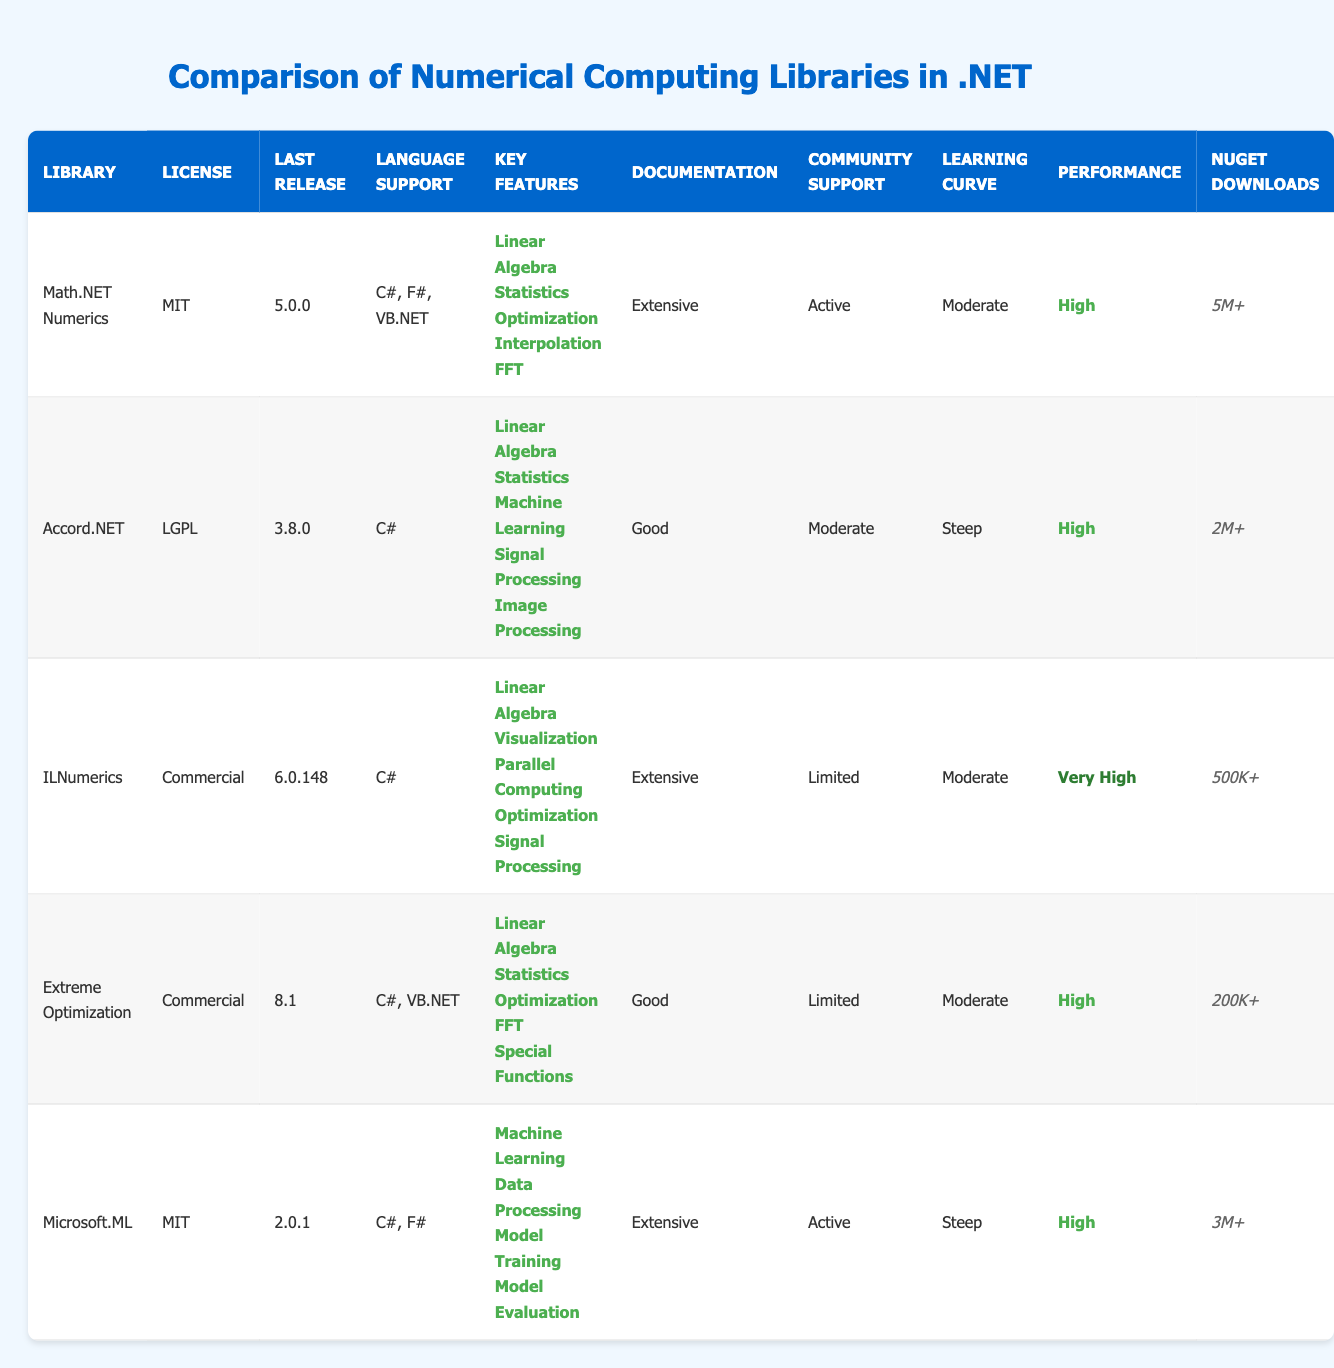What is the last release version of Math.NET Numerics? According to the table, the last release version of Math.NET Numerics is listed in the "Last Release" column as 5.0.0.
Answer: 5.0.0 Which library has the highest NuGet downloads? By comparing the "NuGet Downloads" column, Math.NET Numerics has the highest downloads at 5M+.
Answer: Math.NET Numerics Is ILNumerics community support active? Looking at the "Community Support" column, ILNumerics is marked as having limited community support. Therefore, the statement is false.
Answer: No How many libraries support both C# and F#? By examining the "Language Support" column, Math.NET Numerics and Microsoft.ML support both C# and F#. Thus, there are two libraries that support both languages.
Answer: 2 What is the performance rating of Accord.NET? From the "Performance" column, Accord.NET has a rating of High.
Answer: High Does Extreme Optimization provide features for image processing? The "Key Features" column for Extreme Optimization does not mention image processing. Therefore, it does not provide this feature.
Answer: No Which library has a steeper learning curve, Accord.NET or Microsoft.ML? Comparing the "Learning Curve" column, both Accord.NET and Microsoft.ML are rated as steep. Therefore, they are equally on the steep learning curve.
Answer: They are equal What features are present in both Math.NET Numerics and Accord.NET? To find common features, we look at the key features of both libraries: Math.NET Numerics has Linear Algebra, Statistics, and Optimization, while Accord.NET offers Linear Algebra and Statistics. Both libraries have Linear Algebra and Statistics in common.
Answer: Linear Algebra, Statistics Which library has the least documentation rating? In the "Documentation" column, ILNumerics has a documentation rating of Extensive, Extreme Optimization and Accord.NET are rated as Good, and Microsoft.ML has Extensive as well. The one with the least rating is Accord.NET, which has Good.
Answer: Good 